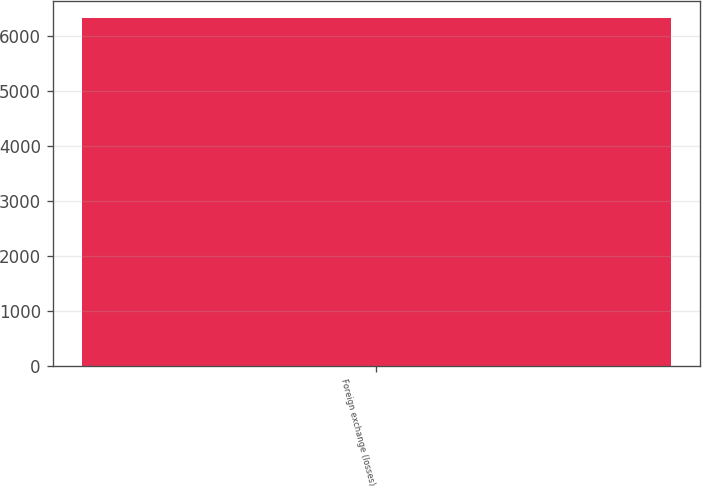Convert chart. <chart><loc_0><loc_0><loc_500><loc_500><bar_chart><fcel>Foreign exchange (losses)<nl><fcel>6328<nl></chart> 